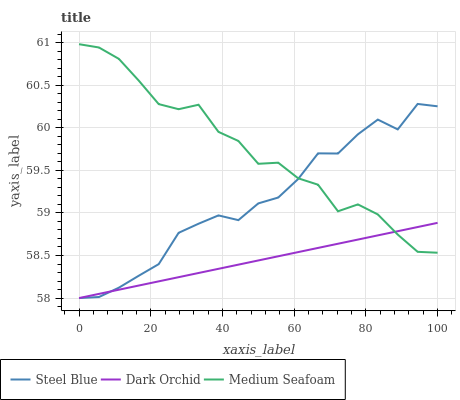Does Dark Orchid have the minimum area under the curve?
Answer yes or no. Yes. Does Medium Seafoam have the maximum area under the curve?
Answer yes or no. Yes. Does Medium Seafoam have the minimum area under the curve?
Answer yes or no. No. Does Dark Orchid have the maximum area under the curve?
Answer yes or no. No. Is Dark Orchid the smoothest?
Answer yes or no. Yes. Is Medium Seafoam the roughest?
Answer yes or no. Yes. Is Medium Seafoam the smoothest?
Answer yes or no. No. Is Dark Orchid the roughest?
Answer yes or no. No. Does Steel Blue have the lowest value?
Answer yes or no. Yes. Does Medium Seafoam have the lowest value?
Answer yes or no. No. Does Medium Seafoam have the highest value?
Answer yes or no. Yes. Does Dark Orchid have the highest value?
Answer yes or no. No. Does Dark Orchid intersect Medium Seafoam?
Answer yes or no. Yes. Is Dark Orchid less than Medium Seafoam?
Answer yes or no. No. Is Dark Orchid greater than Medium Seafoam?
Answer yes or no. No. 